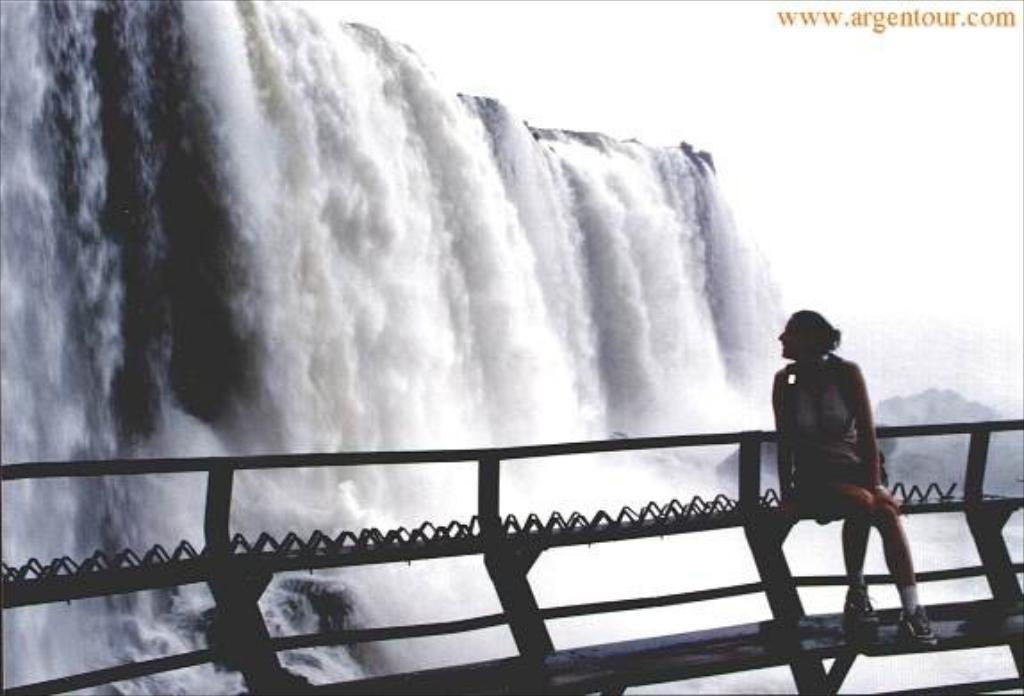What is the woman sitting on in the image? The woman is sitting on a metal object in the image. Where is the metal object located? The metal object is at a fence. What can be seen in the background of the image? There is a waterfall and the sky visible in the background of the image. Is there any text present in the image? Yes, there is text written at the top of the image. What type of vest is the woman wearing in the image? There is no vest visible in the image; the woman is not wearing any clothing that resembles a vest. 